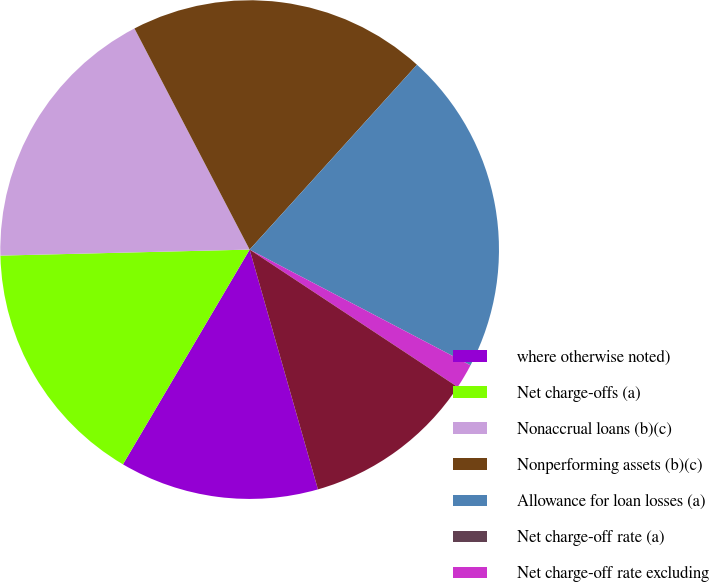Convert chart to OTSL. <chart><loc_0><loc_0><loc_500><loc_500><pie_chart><fcel>where otherwise noted)<fcel>Net charge-offs (a)<fcel>Nonaccrual loans (b)(c)<fcel>Nonperforming assets (b)(c)<fcel>Allowance for loan losses (a)<fcel>Net charge-off rate (a)<fcel>Net charge-off rate excluding<fcel>Allowance for loan losses to<nl><fcel>12.9%<fcel>16.13%<fcel>17.74%<fcel>19.35%<fcel>20.97%<fcel>0.0%<fcel>1.61%<fcel>11.29%<nl></chart> 